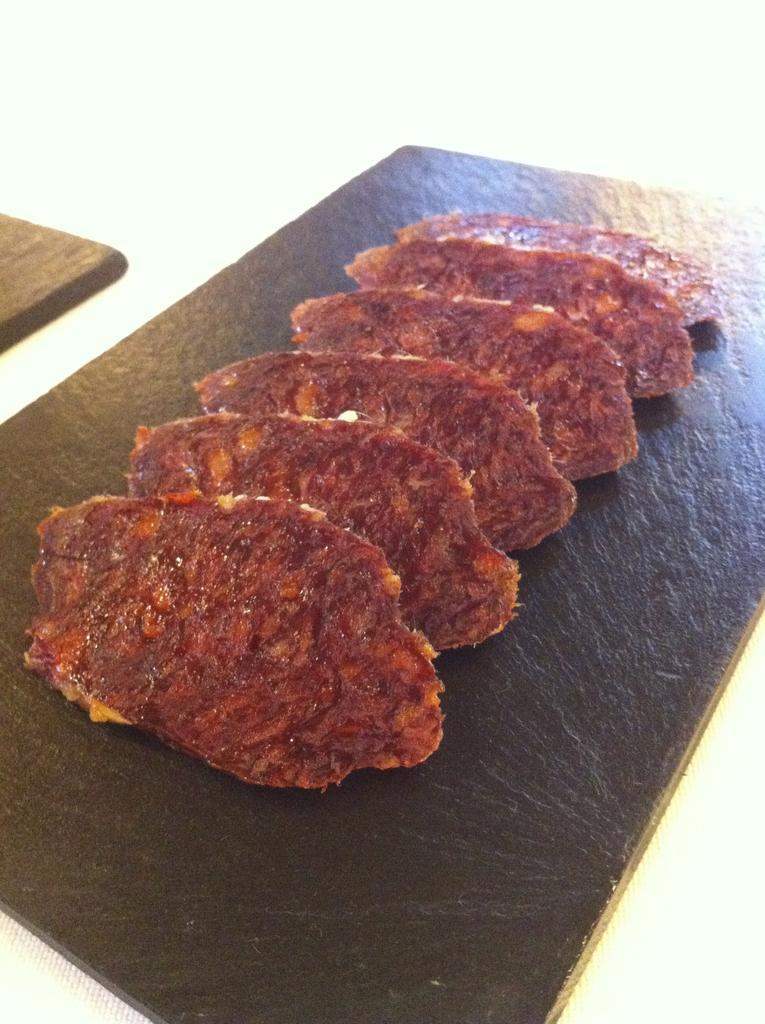Can you describe this image briefly? In this image there is food on a wooden object, the background of the image is white in color. 